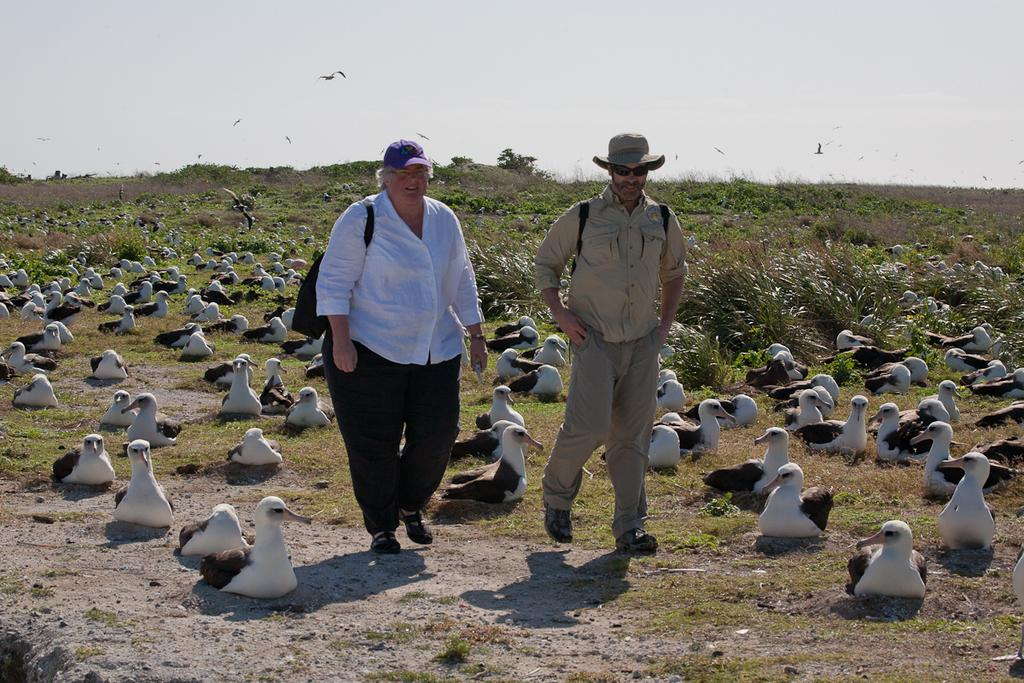How many people are walking in the image? There are two persons walking in the image. What is the surface on which the persons are walking? The persons are walking on the ground. What type of animals can be seen in the image? There are birds visible in the image. What type of vegetation is present in the image? There are plants and grass in the image. What is visible in the background of the image? The sky is visible in the background of the image. What type of shoe is the father wearing in the image? There is no father present in the image, and therefore no shoes to describe. 